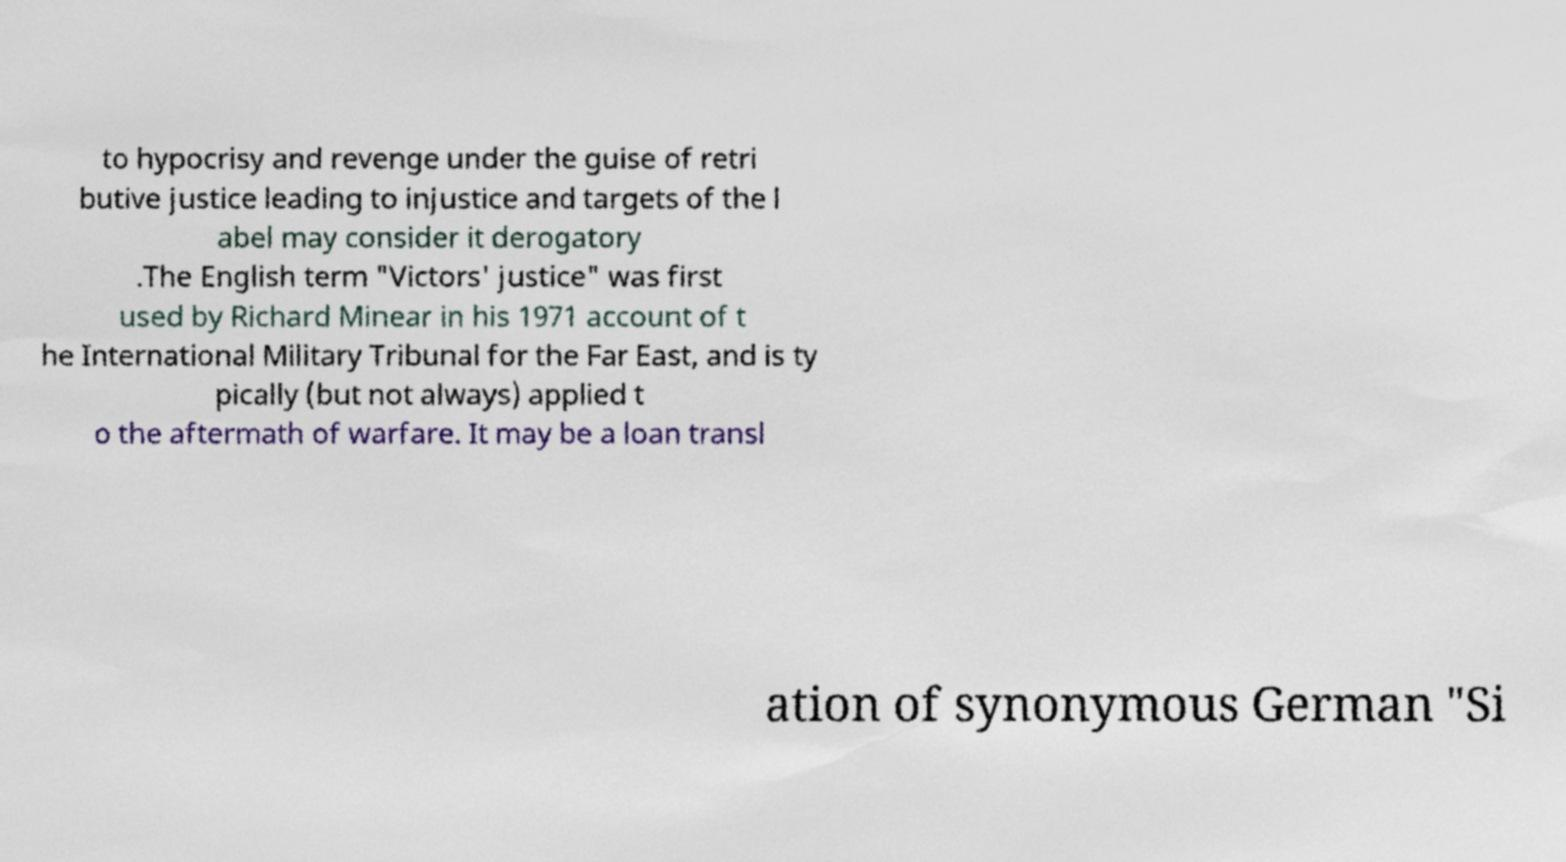Please identify and transcribe the text found in this image. to hypocrisy and revenge under the guise of retri butive justice leading to injustice and targets of the l abel may consider it derogatory .The English term "Victors' justice" was first used by Richard Minear in his 1971 account of t he International Military Tribunal for the Far East, and is ty pically (but not always) applied t o the aftermath of warfare. It may be a loan transl ation of synonymous German "Si 